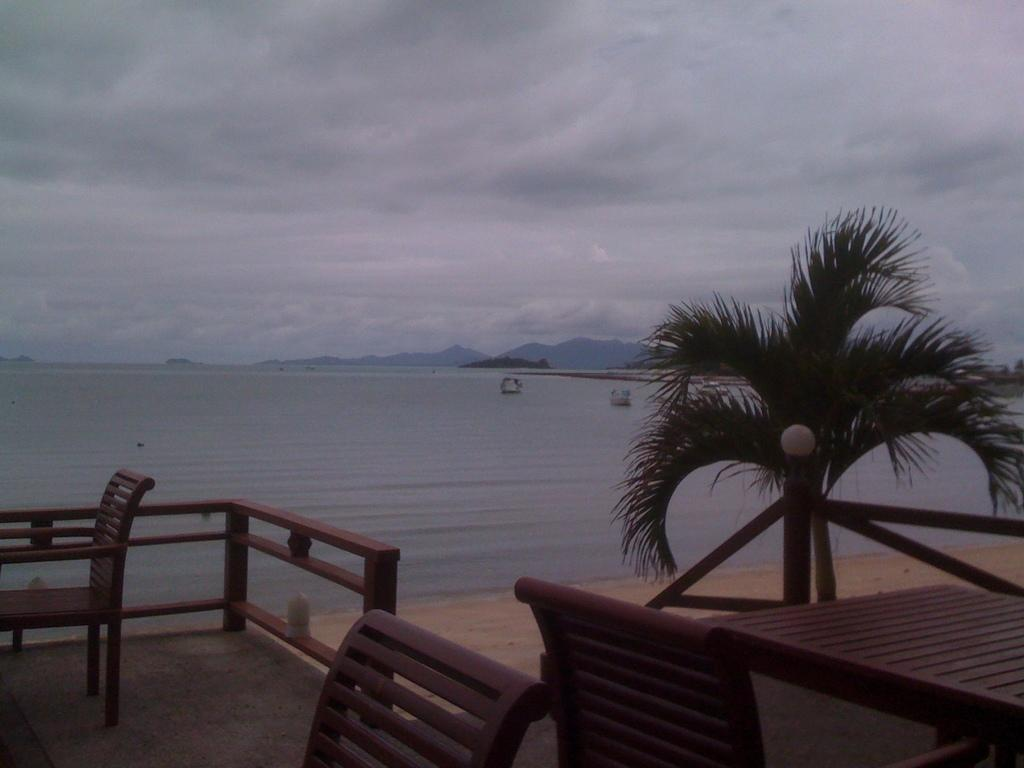What type of furniture can be seen in the image? There are chairs in the image. What architectural feature is present in the image? There is a railing in the image. What is the primary object on which items might be placed in the image? There is a table in the image. What type of plant is visible in the image? There is a plant in the image. What can be seen in the background of the image? Boats, water, waves, hills, and the sky are visible in the background of the image. Is there a donkey celebrating a birthday with a glass of juice in the image? No, there is no donkey, birthday celebration, or glass of juice present in the image. 